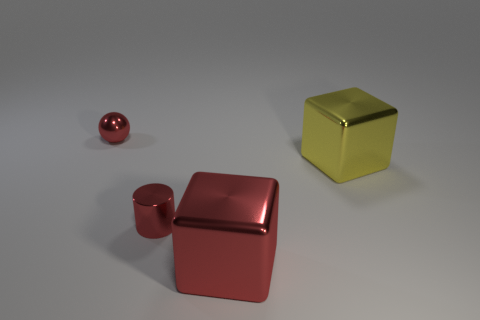Add 3 big gray cubes. How many objects exist? 7 Subtract all yellow blocks. How many blocks are left? 1 Subtract all cylinders. How many objects are left? 3 Add 2 yellow things. How many yellow things exist? 3 Subtract 0 blue balls. How many objects are left? 4 Subtract all small cyan matte cylinders. Subtract all small red cylinders. How many objects are left? 3 Add 2 small red metal things. How many small red metal things are left? 4 